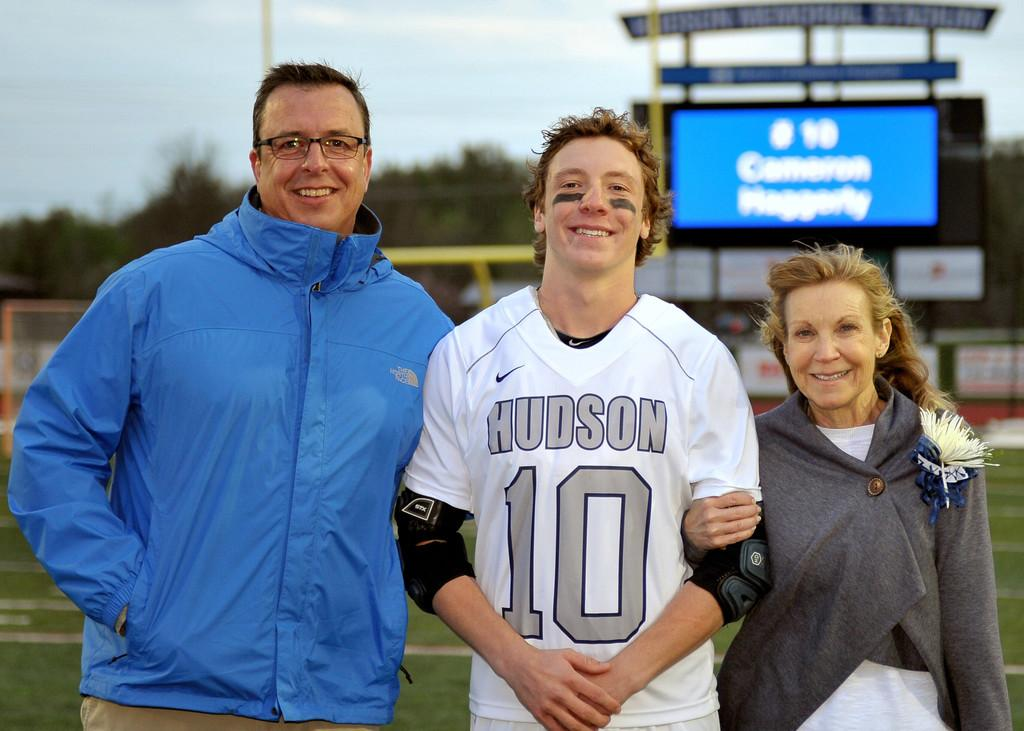<image>
Offer a succinct explanation of the picture presented. Looking proud, Cameron Haggerty of the Hudson football team has his mom and dad on either side of him beaming for the camera. 